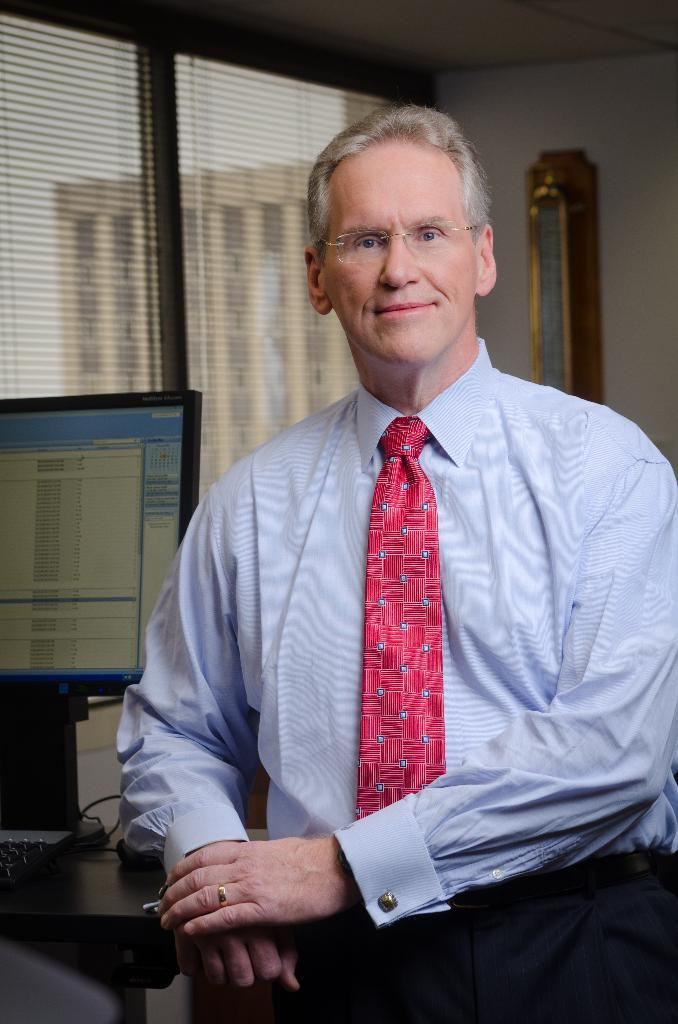What type of furniture is in the image? There is a table in the image. What is on the table? A monitor is present on the table. What can be seen in the left corner of the image? There are windows in the left corner of the image. Who or what is in the foreground of the image? There is a person in the foreground of the image. What is on the wall in the background of the image? There is a wall with an object on it in the background. What song is the person in the foreground of the image singing? There is no indication in the image that the person is singing, and therefore no song can be identified. How quiet is the room in the image? The image does not provide any information about the noise level in the room, so it cannot be determined from the image. 